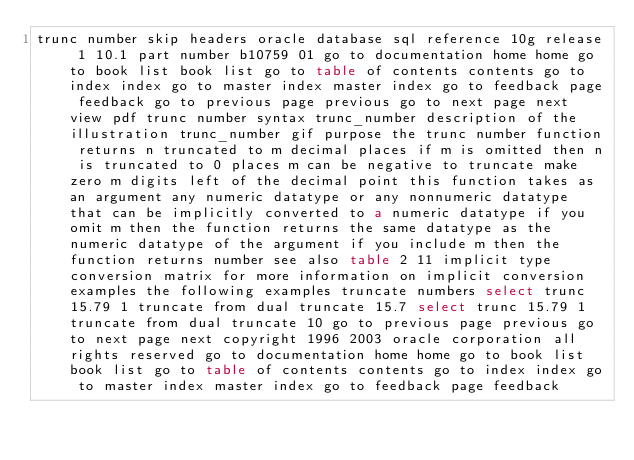Convert code to text. <code><loc_0><loc_0><loc_500><loc_500><_HTML_>trunc number skip headers oracle database sql reference 10g release 1 10.1 part number b10759 01 go to documentation home home go to book list book list go to table of contents contents go to index index go to master index master index go to feedback page feedback go to previous page previous go to next page next view pdf trunc number syntax trunc_number description of the illustration trunc_number gif purpose the trunc number function returns n truncated to m decimal places if m is omitted then n is truncated to 0 places m can be negative to truncate make zero m digits left of the decimal point this function takes as an argument any numeric datatype or any nonnumeric datatype that can be implicitly converted to a numeric datatype if you omit m then the function returns the same datatype as the numeric datatype of the argument if you include m then the function returns number see also table 2 11 implicit type conversion matrix for more information on implicit conversion examples the following examples truncate numbers select trunc 15.79 1 truncate from dual truncate 15.7 select trunc 15.79 1 truncate from dual truncate 10 go to previous page previous go to next page next copyright 1996 2003 oracle corporation all rights reserved go to documentation home home go to book list book list go to table of contents contents go to index index go to master index master index go to feedback page feedback
</code> 